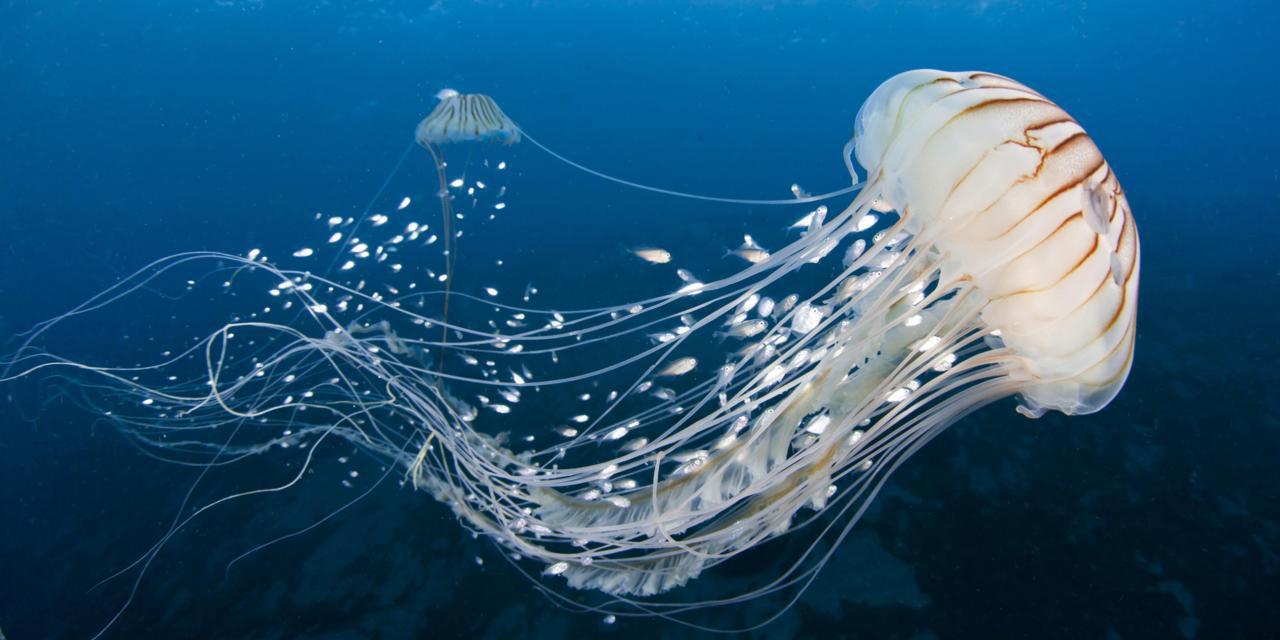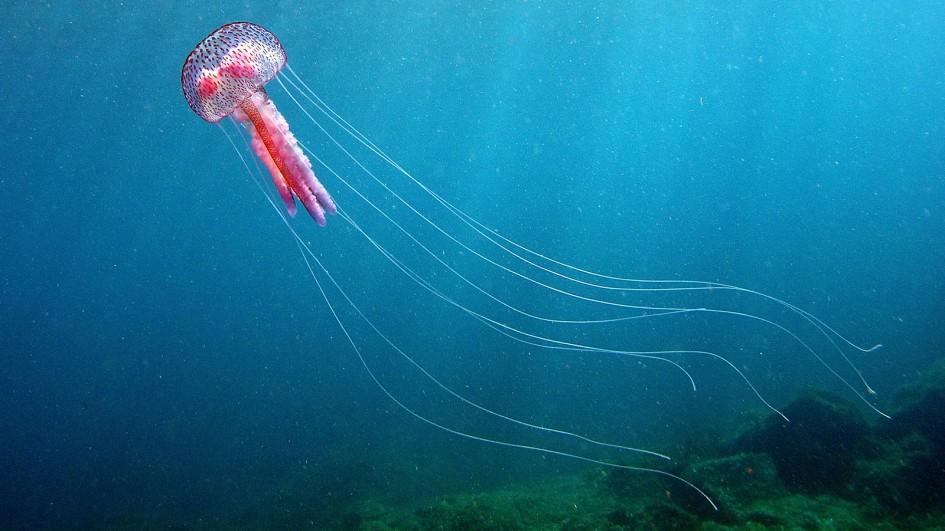The first image is the image on the left, the second image is the image on the right. Evaluate the accuracy of this statement regarding the images: "There are 3 jellyfish.". Is it true? Answer yes or no. Yes. 